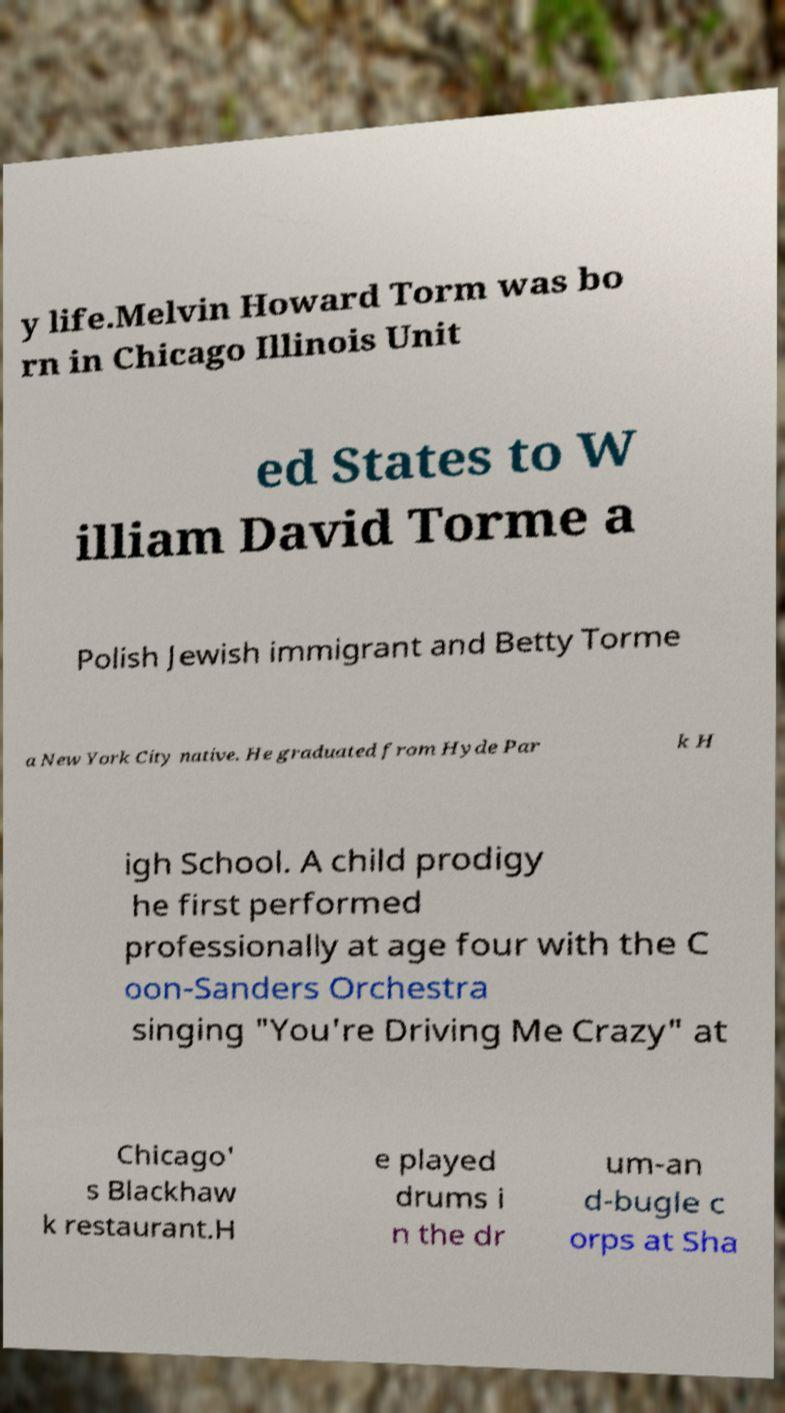Can you read and provide the text displayed in the image?This photo seems to have some interesting text. Can you extract and type it out for me? y life.Melvin Howard Torm was bo rn in Chicago Illinois Unit ed States to W illiam David Torme a Polish Jewish immigrant and Betty Torme a New York City native. He graduated from Hyde Par k H igh School. A child prodigy he first performed professionally at age four with the C oon-Sanders Orchestra singing "You're Driving Me Crazy" at Chicago' s Blackhaw k restaurant.H e played drums i n the dr um-an d-bugle c orps at Sha 